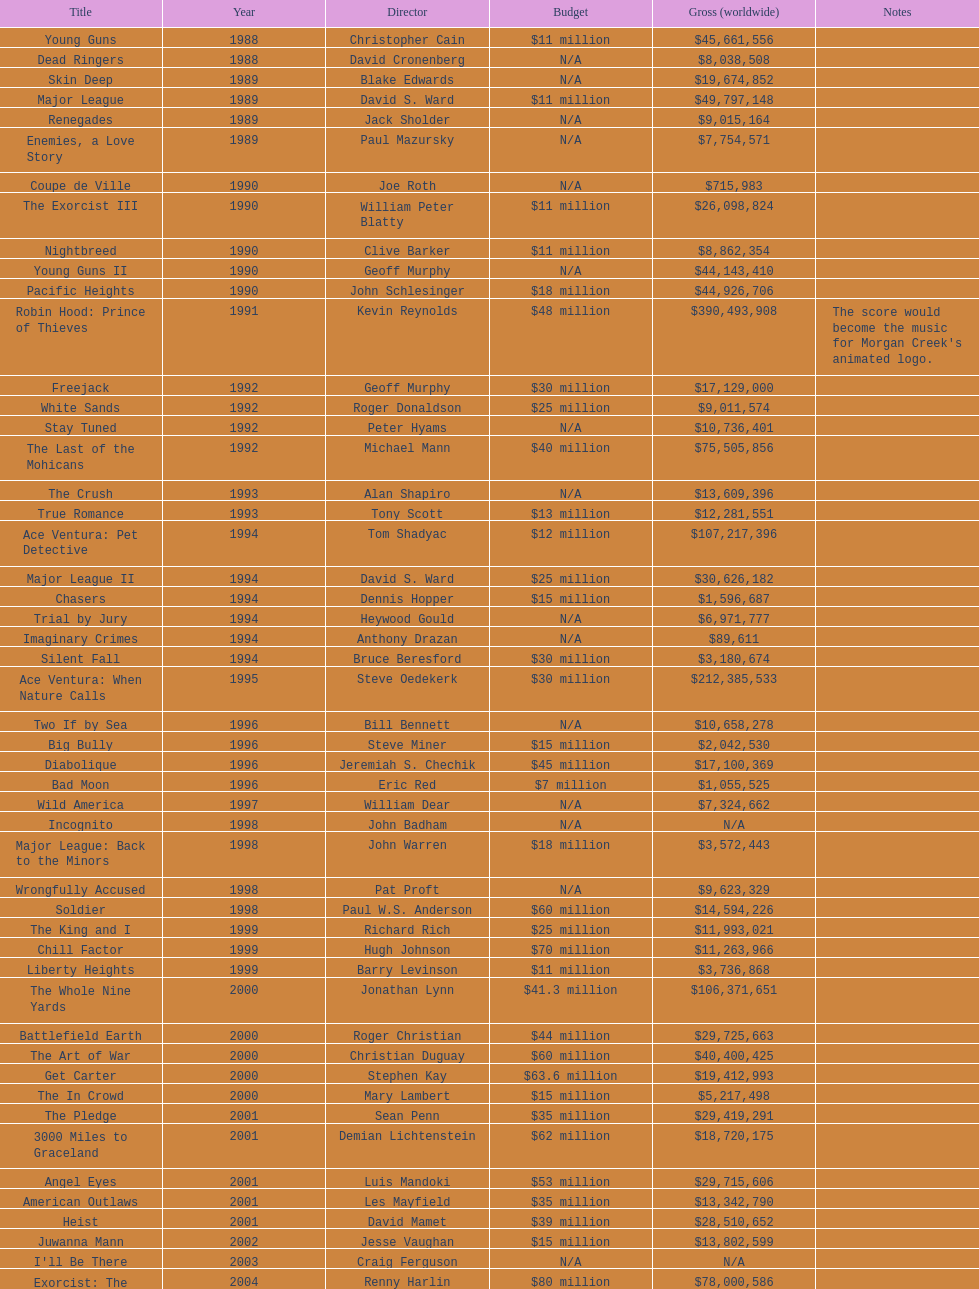What movie was made immediately before the pledge? The In Crowd. 